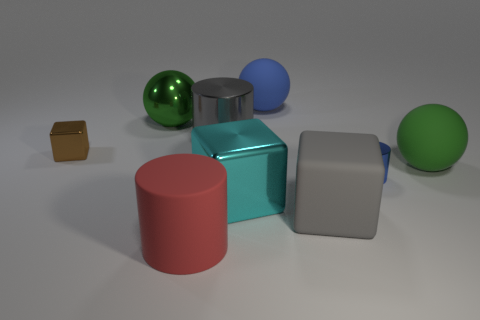Add 1 yellow balls. How many objects exist? 10 Subtract all cylinders. How many objects are left? 6 Add 3 small cylinders. How many small cylinders exist? 4 Subtract 1 red cylinders. How many objects are left? 8 Subtract all gray metal objects. Subtract all big cylinders. How many objects are left? 6 Add 4 blue rubber things. How many blue rubber things are left? 5 